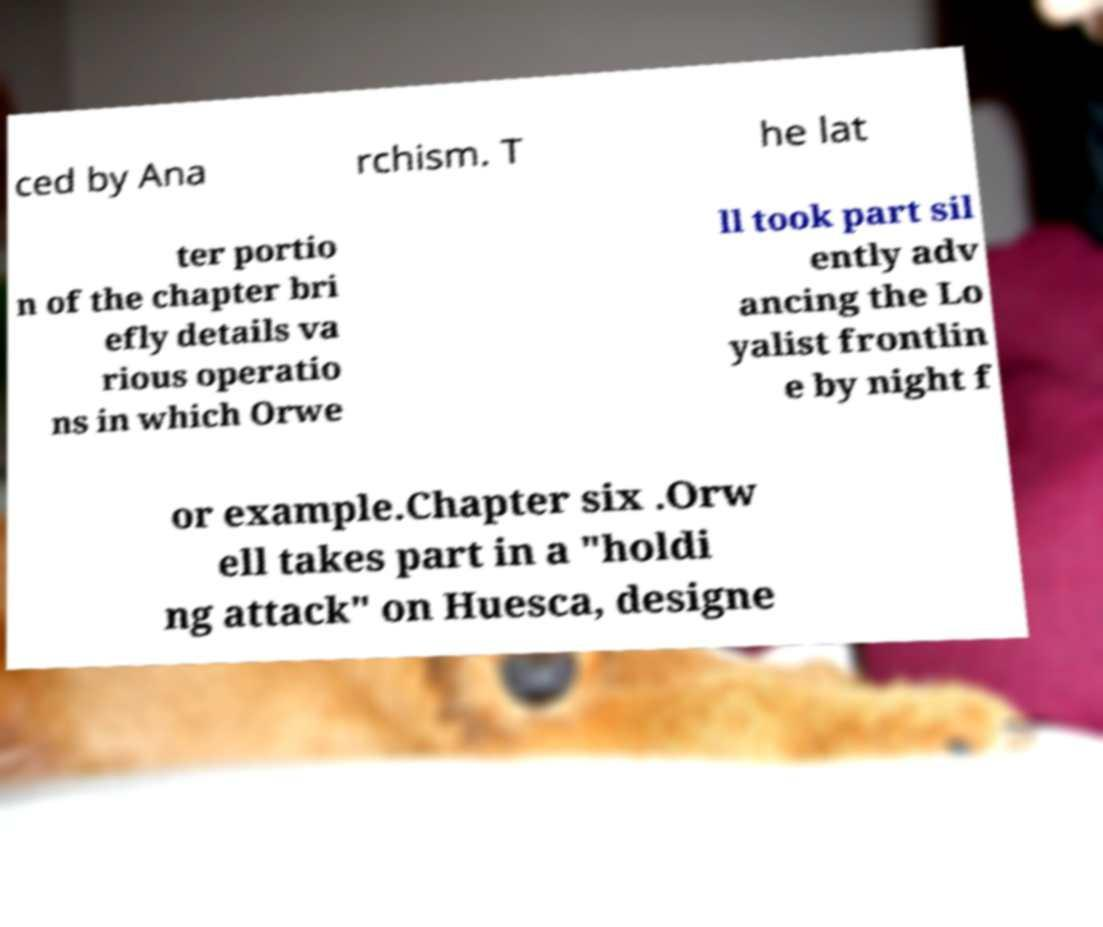Can you read and provide the text displayed in the image?This photo seems to have some interesting text. Can you extract and type it out for me? ced by Ana rchism. T he lat ter portio n of the chapter bri efly details va rious operatio ns in which Orwe ll took part sil ently adv ancing the Lo yalist frontlin e by night f or example.Chapter six .Orw ell takes part in a "holdi ng attack" on Huesca, designe 